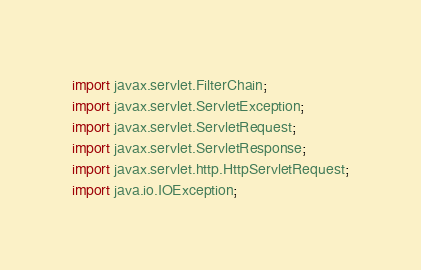<code> <loc_0><loc_0><loc_500><loc_500><_Java_>import javax.servlet.FilterChain;
import javax.servlet.ServletException;
import javax.servlet.ServletRequest;
import javax.servlet.ServletResponse;
import javax.servlet.http.HttpServletRequest;
import java.io.IOException;
</code> 